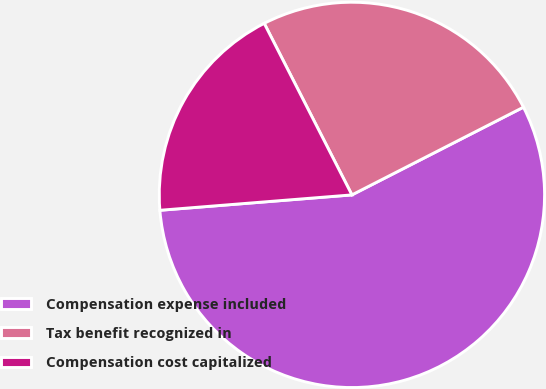<chart> <loc_0><loc_0><loc_500><loc_500><pie_chart><fcel>Compensation expense included<fcel>Tax benefit recognized in<fcel>Compensation cost capitalized<nl><fcel>56.25%<fcel>25.0%<fcel>18.75%<nl></chart> 